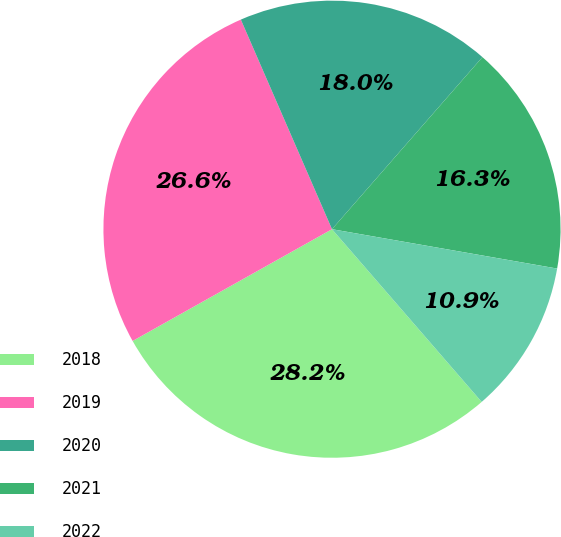Convert chart. <chart><loc_0><loc_0><loc_500><loc_500><pie_chart><fcel>2018<fcel>2019<fcel>2020<fcel>2021<fcel>2022<nl><fcel>28.23%<fcel>26.6%<fcel>17.96%<fcel>16.32%<fcel>10.88%<nl></chart> 